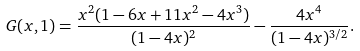Convert formula to latex. <formula><loc_0><loc_0><loc_500><loc_500>G ( x , 1 ) = \frac { x ^ { 2 } ( 1 - 6 x + 1 1 x ^ { 2 } - 4 x ^ { 3 } ) } { ( 1 - 4 x ) ^ { 2 } } - \frac { 4 x ^ { 4 } } { ( 1 - 4 x ) ^ { 3 / 2 } } .</formula> 